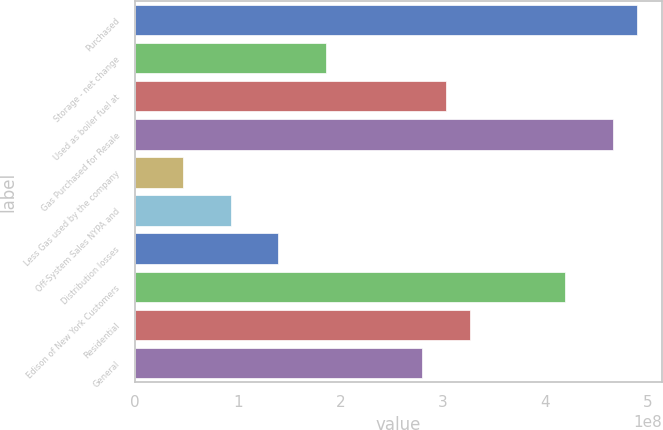<chart> <loc_0><loc_0><loc_500><loc_500><bar_chart><fcel>Purchased<fcel>Storage - net change<fcel>Used as boiler fuel at<fcel>Gas Purchased for Resale<fcel>Less Gas used by the company<fcel>Off-System Sales NYPA and<fcel>Distribution losses<fcel>Edison of New York Customers<fcel>Residential<fcel>General<nl><fcel>4.89254e+08<fcel>1.86383e+08<fcel>3.02872e+08<fcel>4.65957e+08<fcel>4.65957e+07<fcel>9.31913e+07<fcel>1.39787e+08<fcel>4.19361e+08<fcel>3.2617e+08<fcel>2.79574e+08<nl></chart> 